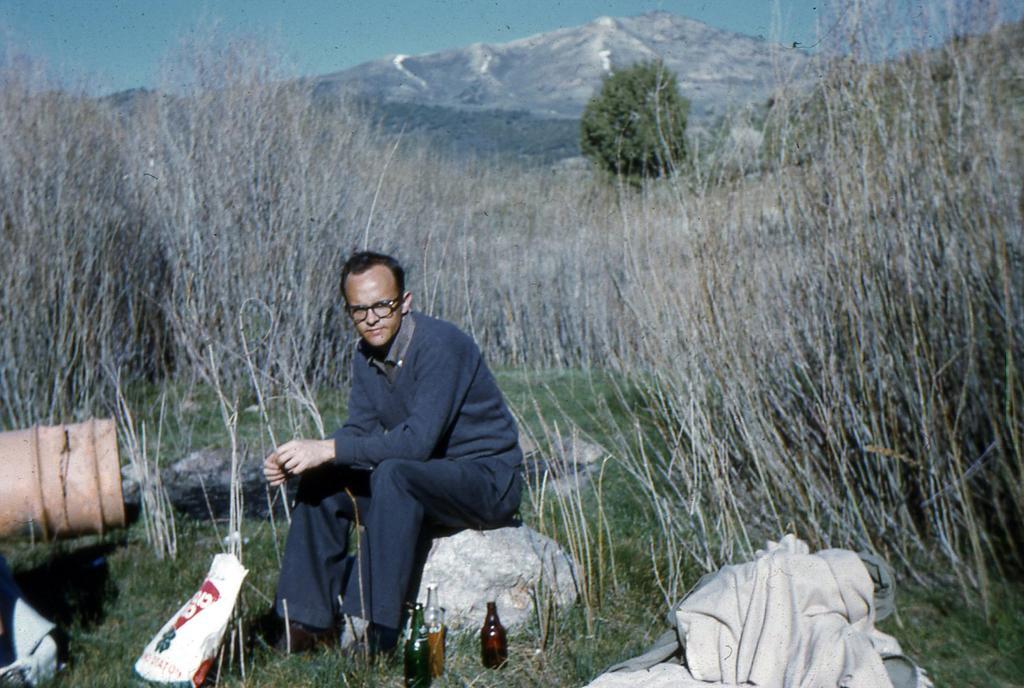In one or two sentences, can you explain what this image depicts? It is looking like a hill station a man is sitting on the rock, beside him there are some bottles, in front of him there is a cover, to the right side there are few clothes, beside the man there is a grass on the floor behind it there are some dry trees in the background there is a mountain and sky. 